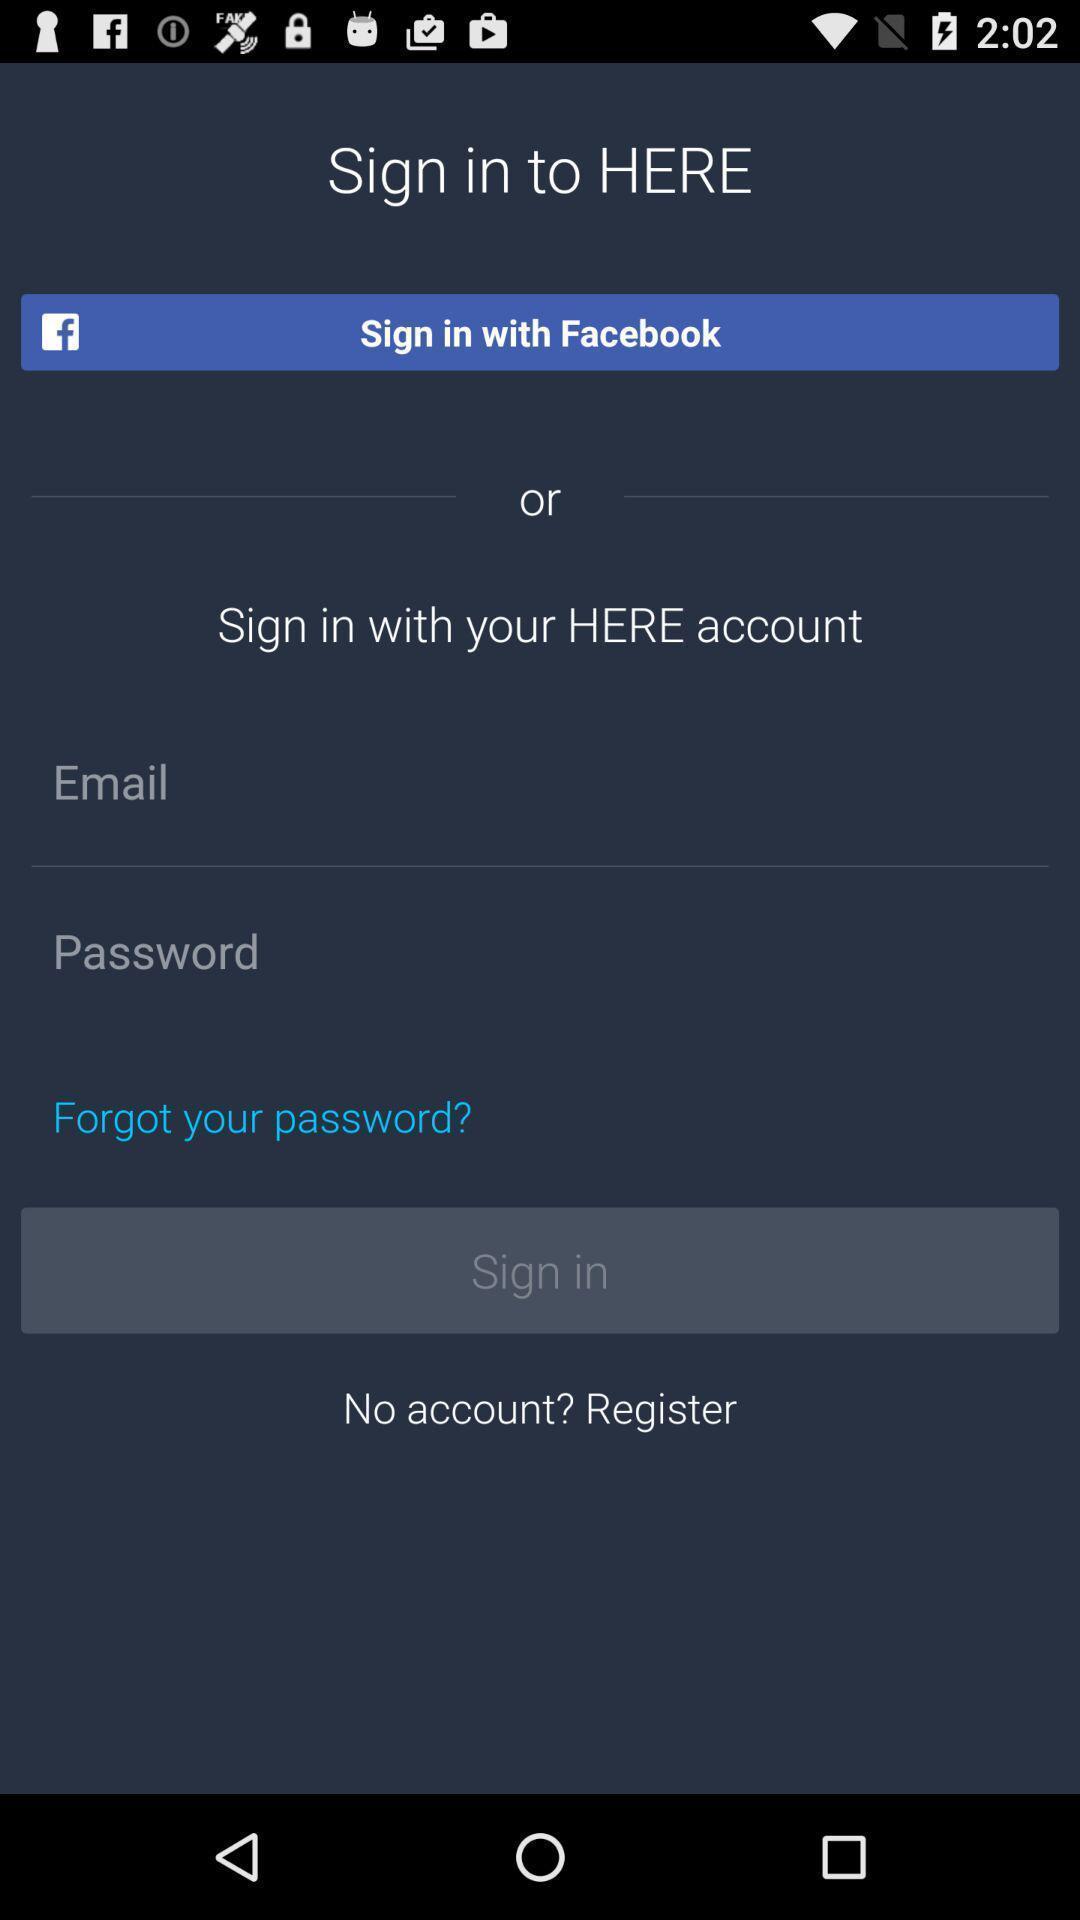Summarize the main components in this picture. Welcome page asking for login details. 